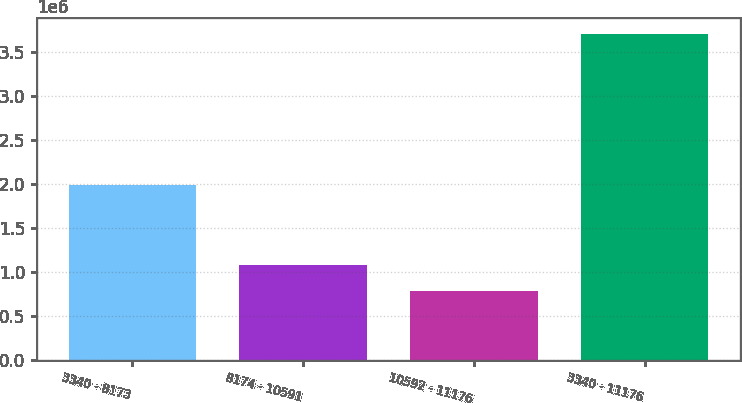Convert chart. <chart><loc_0><loc_0><loc_500><loc_500><bar_chart><fcel>3340 - 8173<fcel>8174 - 10591<fcel>10592 - 11176<fcel>3340 - 11176<nl><fcel>1.98508e+06<fcel>1.07661e+06<fcel>785186<fcel>3.69947e+06<nl></chart> 